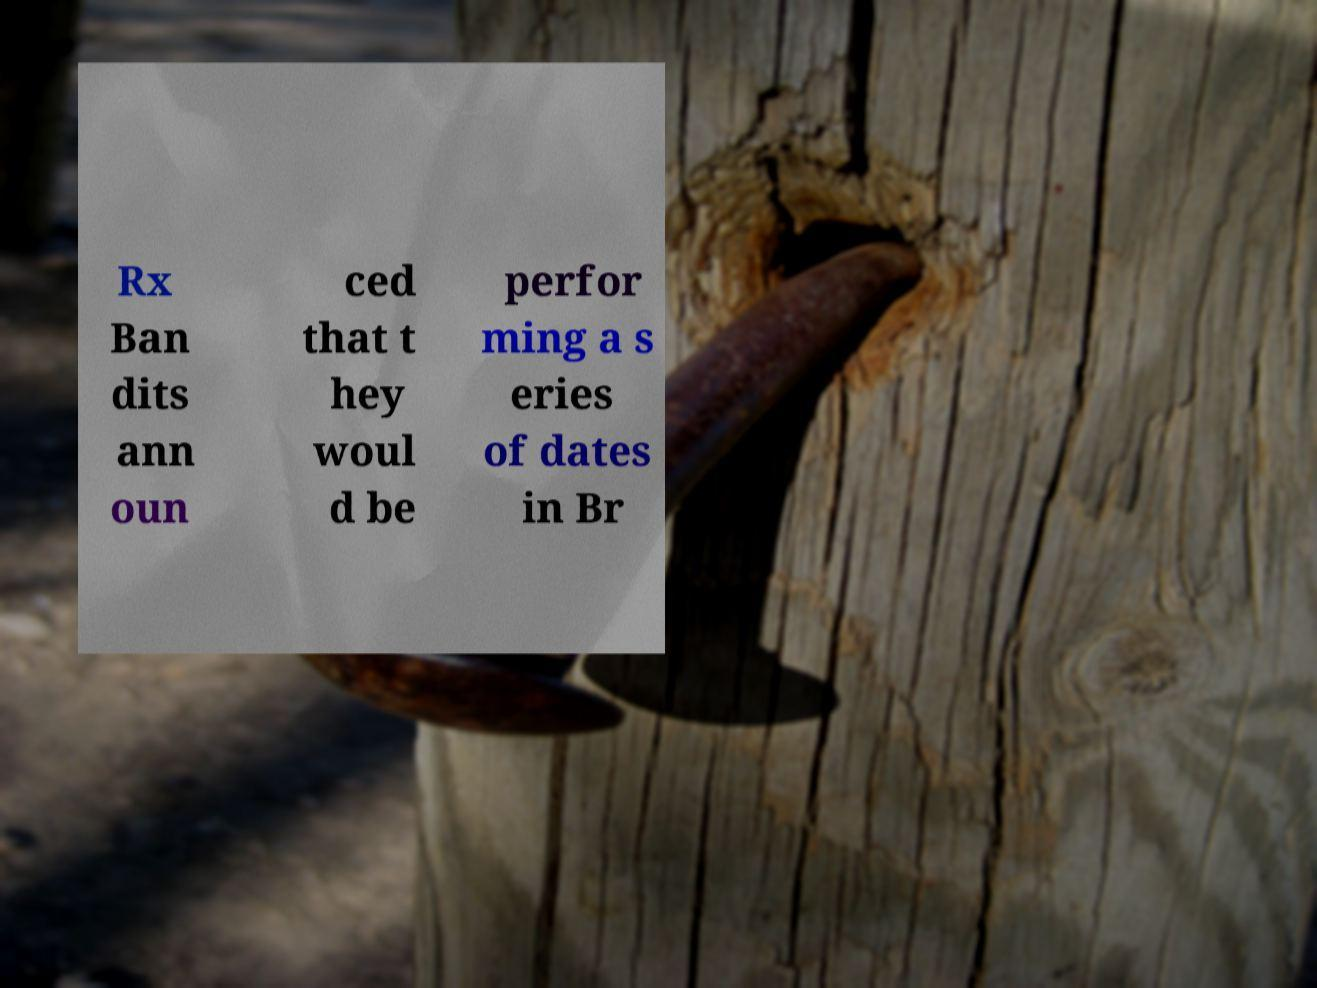Please read and relay the text visible in this image. What does it say? Rx Ban dits ann oun ced that t hey woul d be perfor ming a s eries of dates in Br 